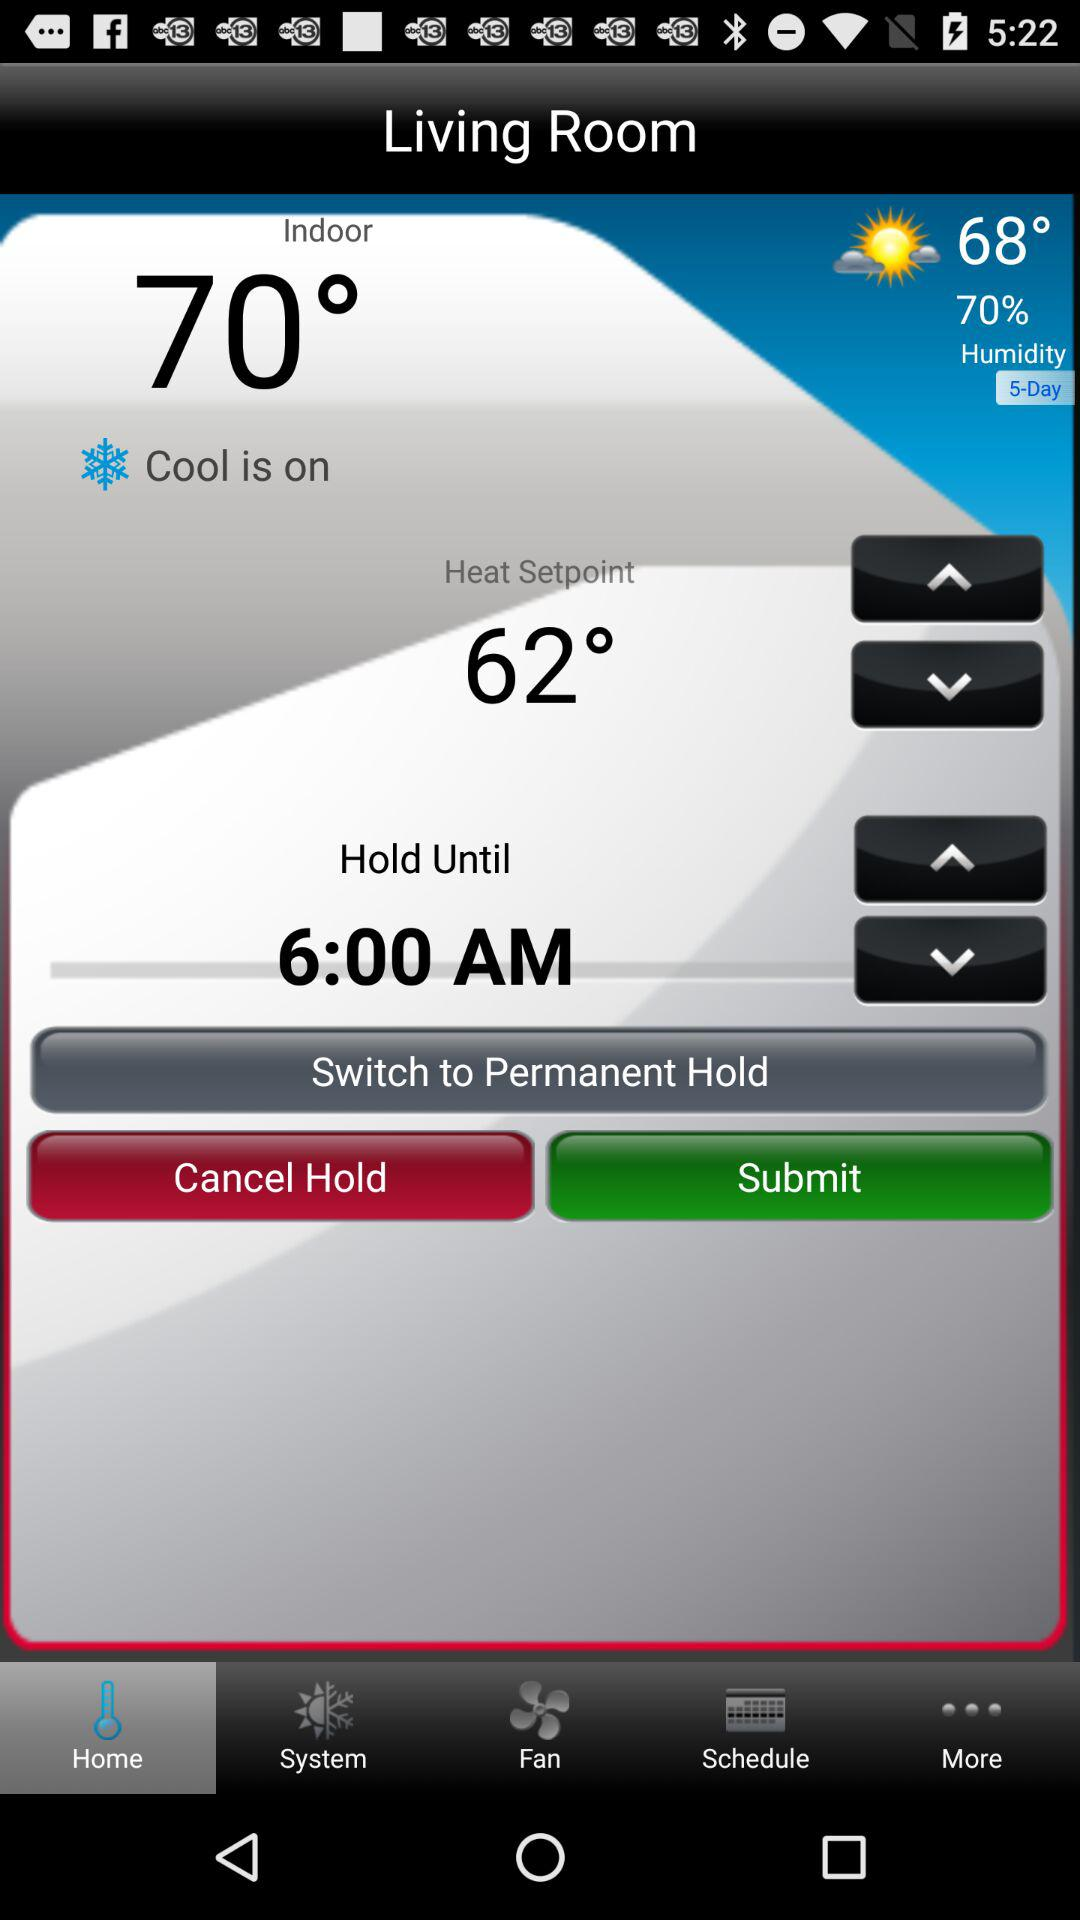What is the current humidity?
Answer the question using a single word or phrase. 70% 